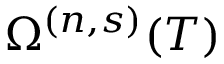<formula> <loc_0><loc_0><loc_500><loc_500>\Omega ^ { ( n , s ) } ( T )</formula> 